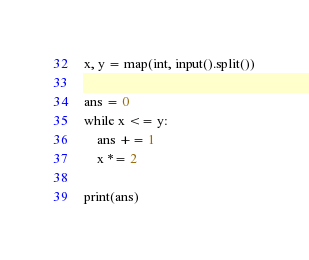Convert code to text. <code><loc_0><loc_0><loc_500><loc_500><_Python_>x, y = map(int, input().split())

ans = 0
while x <= y:
    ans += 1
    x *= 2

print(ans)</code> 